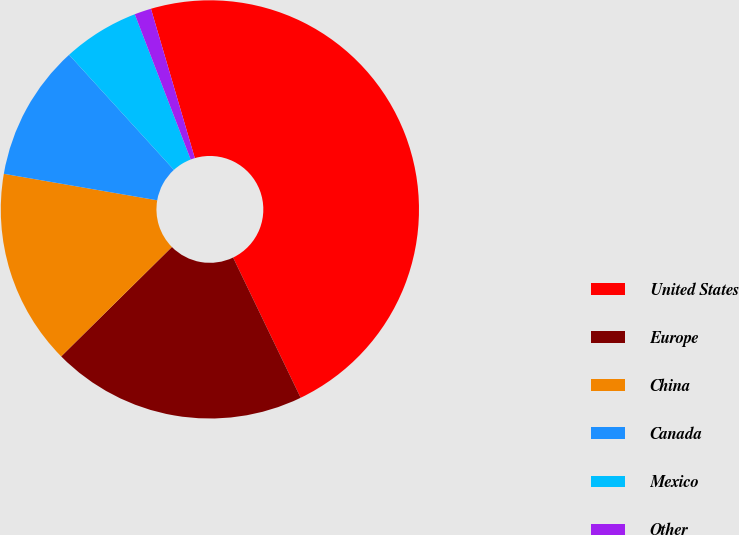Convert chart. <chart><loc_0><loc_0><loc_500><loc_500><pie_chart><fcel>United States<fcel>Europe<fcel>China<fcel>Canada<fcel>Mexico<fcel>Other<nl><fcel>47.4%<fcel>19.74%<fcel>15.13%<fcel>10.52%<fcel>5.91%<fcel>1.3%<nl></chart> 